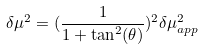Convert formula to latex. <formula><loc_0><loc_0><loc_500><loc_500>\delta \mu ^ { 2 } = ( \frac { 1 } { 1 + \tan ^ { 2 } ( \theta ) } ) ^ { 2 } \delta \mu ^ { 2 } _ { a p p }</formula> 